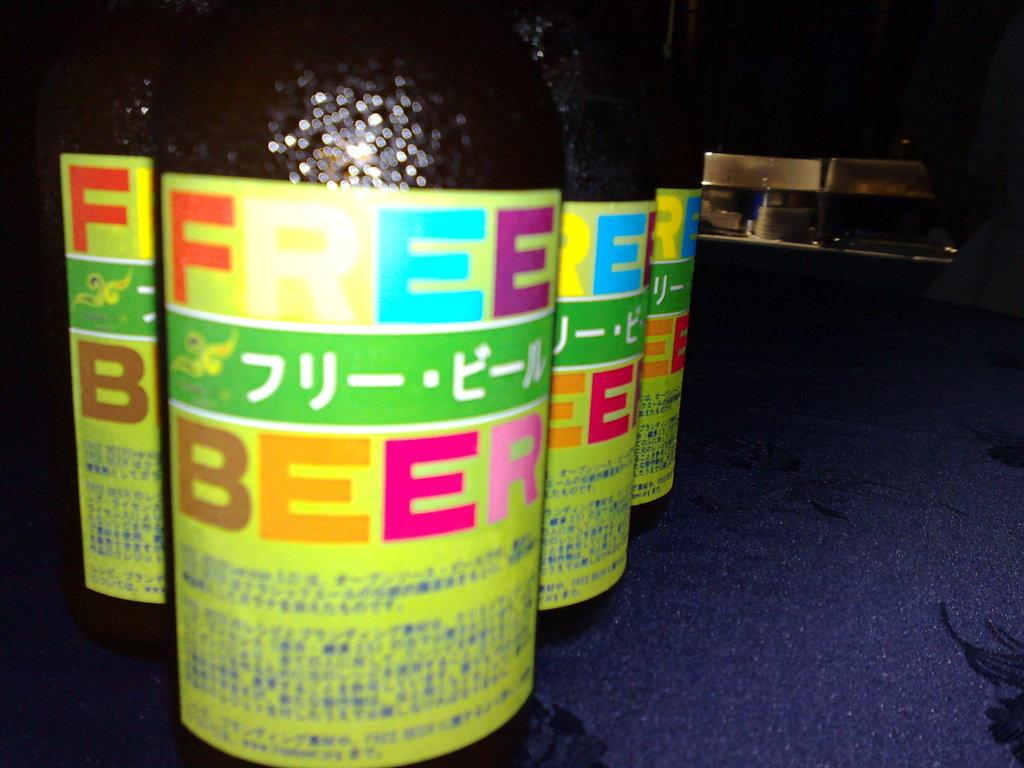<image>
Present a compact description of the photo's key features. A bottle that says "free beer" has a very colorful label. 